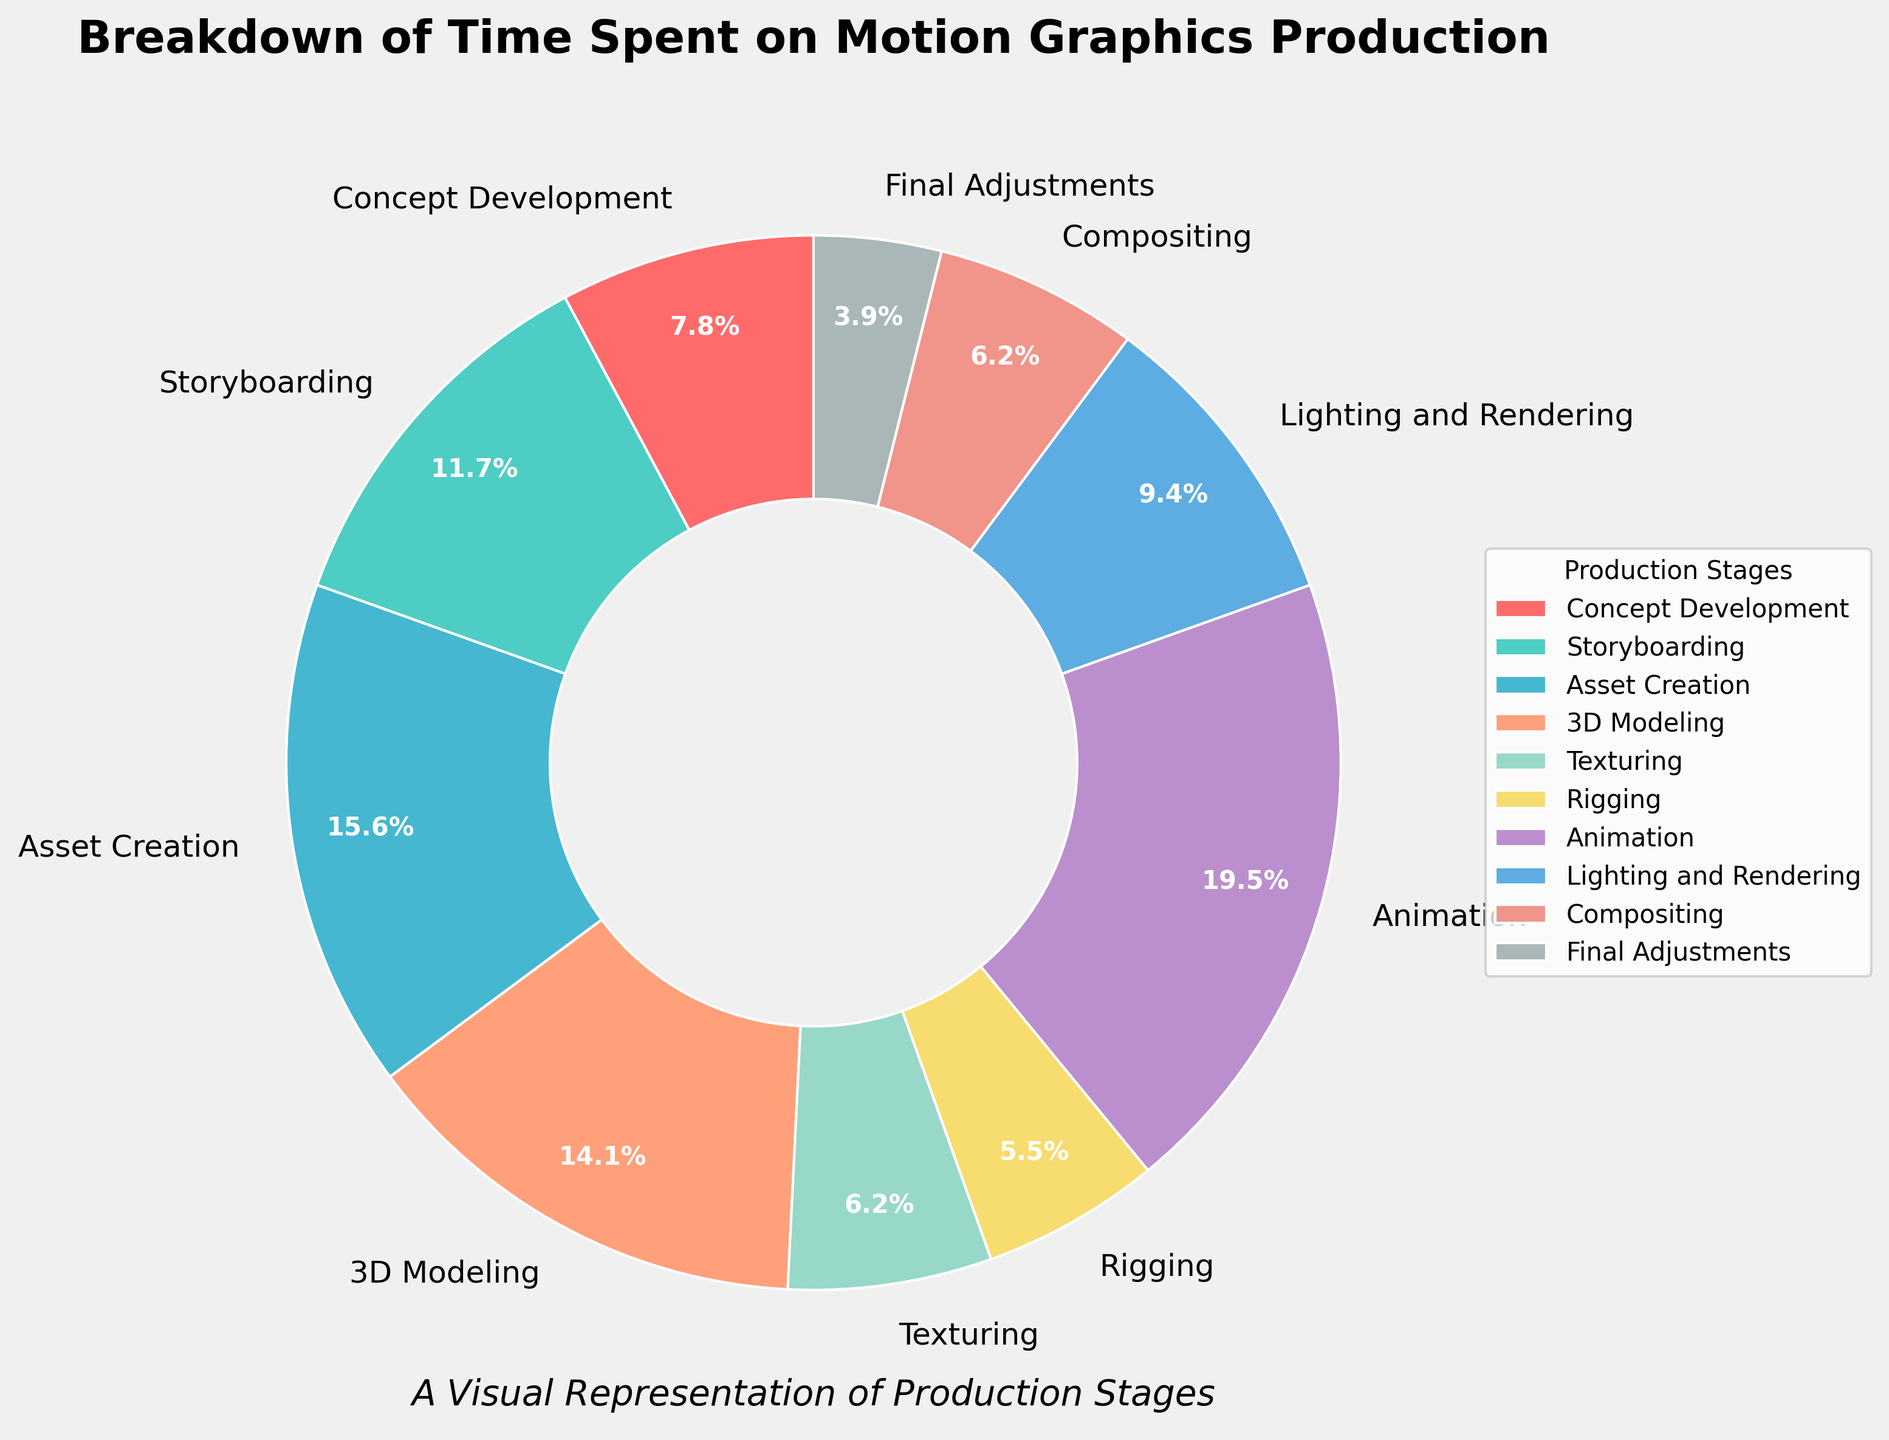What's the largest segment in the pie chart? To determine the largest segment, we look at the percentage values of each stage. The one with the highest percentage is the largest segment. In this case, Animation has the highest percentage at 25%.
Answer: Animation Which stage takes less time: Storyboarding or Texturing? Compare the percentages of Storyboarding and Texturing. Storyboarding has 15%, and Texturing has 8%. Since 8% is less than 15%, Texturing takes less time.
Answer: Texturing What's the difference in time spent between Asset Creation and 3D Modeling? Asset Creation takes 20%, and 3D Modeling takes 18%. The difference is calculated by subtracting the smaller value from the larger value: 20% - 18% = 2%.
Answer: 2% What is the combined percentage for Texturing and Compositing? Add the percentages of Texturing and Compositing. Texturing is 8%, and Compositing is also 8%. So, the combined percentage is 8% + 8% = 16%.
Answer: 16% Which stage has a larger wedge: Rigging or Final Adjustments? Compare the percentages of Rigging and Final Adjustments. Rigging has 7%, and Final Adjustments have 5%. Since 7% is larger than 5%, Rigging has a larger wedge.
Answer: Rigging How many stages take less than or equal to 10% of the total time each? Look at each stage and count those with a percentage of 10% or less: Concept Development (10%), Texturing (8%), Rigging (7%), Compositing (8%), and Final Adjustments (5%). There are 5 stages.
Answer: 5 What percentage of time is spent on creative stages like Concept Development, Storyboarding, and Animation combined? Add the percentages of Concept Development (10%), Storyboarding (15%), and Animation (25%). The total is 10% + 15% + 25% = 50%.
Answer: 50% Is the percentage for Lighting and Rendering higher or lower than for 3D Modeling? Compare the percentages of Lighting and Rendering and 3D Modeling. Lighting and Rendering is 12%, which is lower than 3D Modeling's 18%.
Answer: Lower Identify the second-largest segment in the pie chart. First, identify the largest segment, which is Animation at 25%. The second-largest segment is then found by identifying the next highest percentage, which is Asset Creation at 20%.
Answer: Asset Creation What stages together make up more than 50% of the total time? Identify stages whose combined sum exceeds 50%: Animation (25%), Asset Creation (20%), and Storyboarding (15%). Adding these gives 25% + 20% + 15% = 60%, which is more than 50%.
Answer: Animation, Asset Creation, Storyboarding 